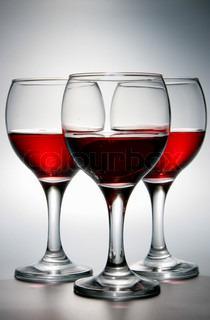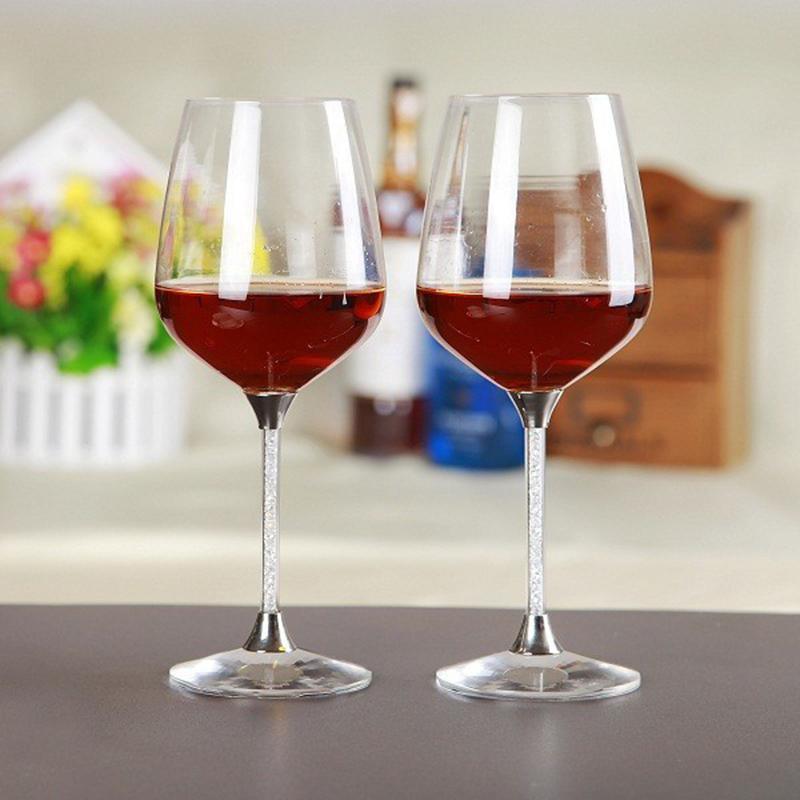The first image is the image on the left, the second image is the image on the right. Evaluate the accuracy of this statement regarding the images: "The image on the right has three glasses of red wine.". Is it true? Answer yes or no. No. The first image is the image on the left, the second image is the image on the right. Analyze the images presented: Is the assertion "Left image shows exactly three half-full wine glasses arranged in a row." valid? Answer yes or no. Yes. 